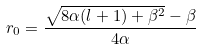Convert formula to latex. <formula><loc_0><loc_0><loc_500><loc_500>r _ { 0 } = \frac { \sqrt { 8 \alpha ( l + 1 ) + \beta ^ { 2 } } - \beta } { 4 \alpha }</formula> 